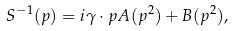Convert formula to latex. <formula><loc_0><loc_0><loc_500><loc_500>S ^ { - 1 } ( p ) = i \gamma \cdot p A ( p ^ { 2 } ) + B ( p ^ { 2 } ) ,</formula> 